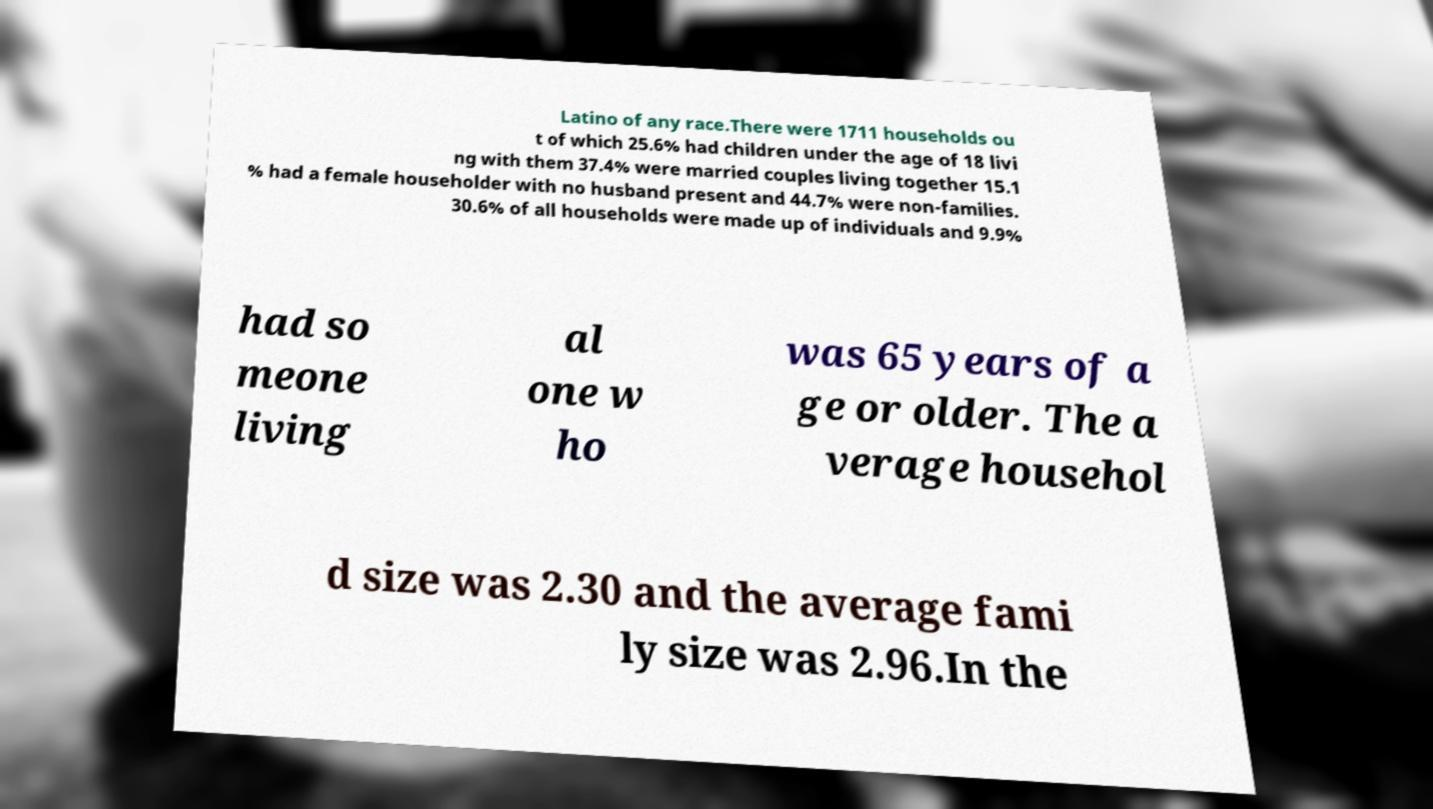Could you assist in decoding the text presented in this image and type it out clearly? Latino of any race.There were 1711 households ou t of which 25.6% had children under the age of 18 livi ng with them 37.4% were married couples living together 15.1 % had a female householder with no husband present and 44.7% were non-families. 30.6% of all households were made up of individuals and 9.9% had so meone living al one w ho was 65 years of a ge or older. The a verage househol d size was 2.30 and the average fami ly size was 2.96.In the 